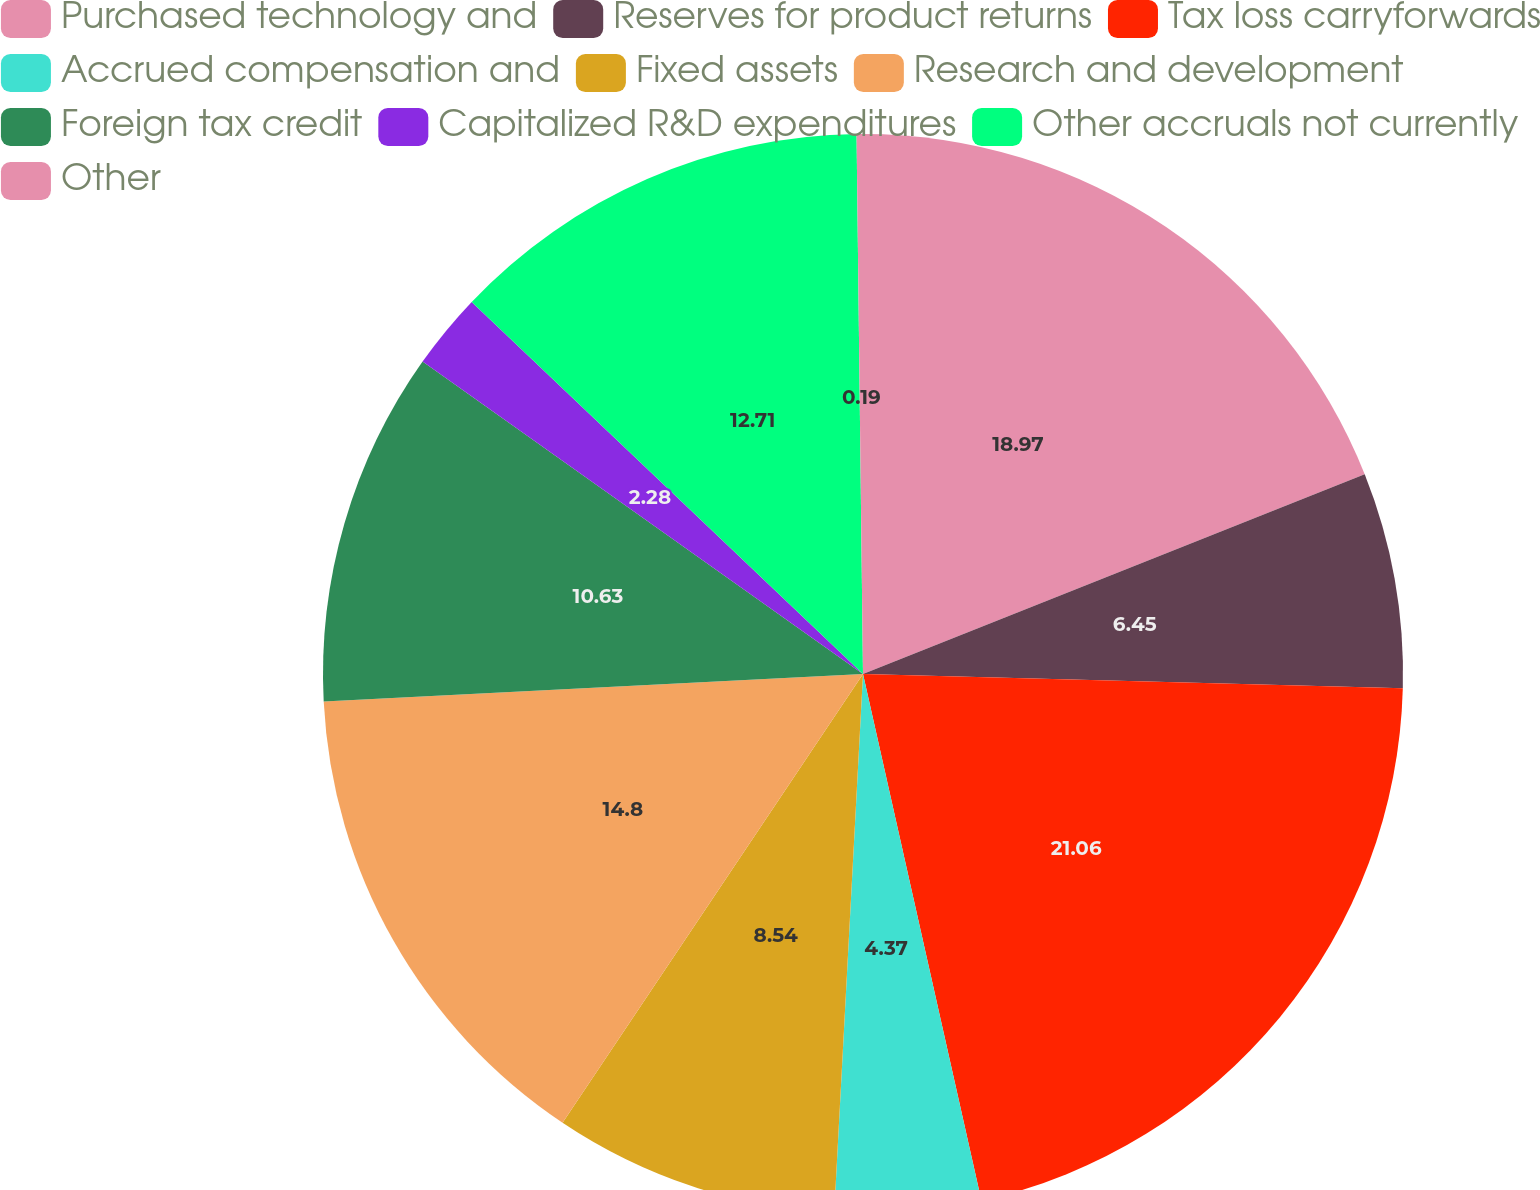<chart> <loc_0><loc_0><loc_500><loc_500><pie_chart><fcel>Purchased technology and<fcel>Reserves for product returns<fcel>Tax loss carryforwards<fcel>Accrued compensation and<fcel>Fixed assets<fcel>Research and development<fcel>Foreign tax credit<fcel>Capitalized R&D expenditures<fcel>Other accruals not currently<fcel>Other<nl><fcel>18.97%<fcel>6.45%<fcel>21.06%<fcel>4.37%<fcel>8.54%<fcel>14.8%<fcel>10.63%<fcel>2.28%<fcel>12.71%<fcel>0.19%<nl></chart> 